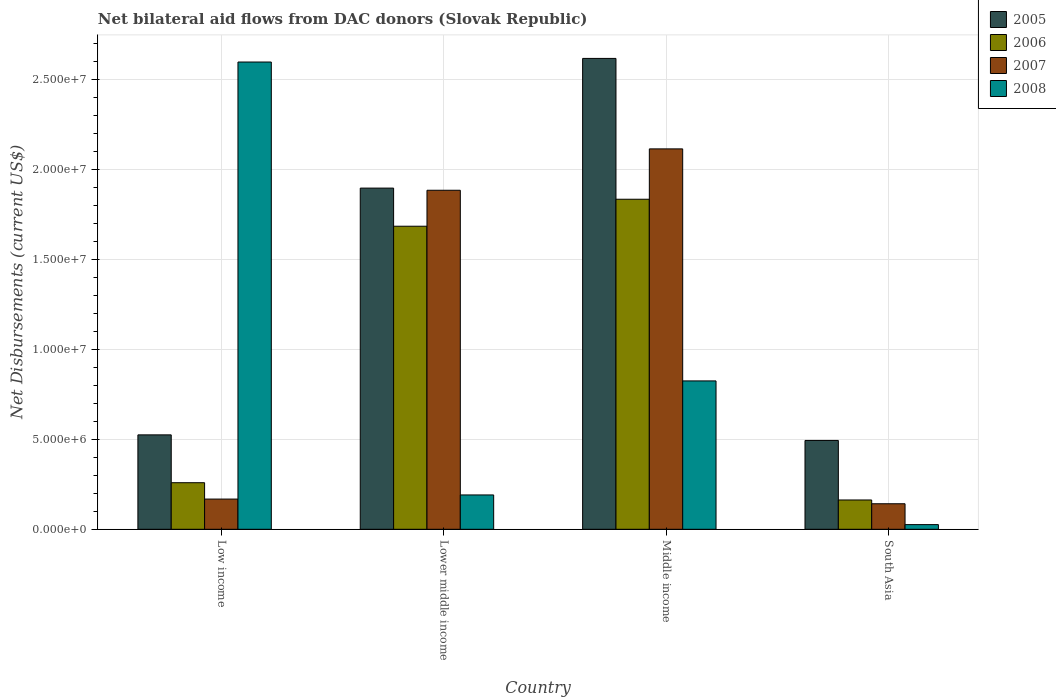Are the number of bars per tick equal to the number of legend labels?
Make the answer very short. Yes. How many bars are there on the 2nd tick from the left?
Offer a very short reply. 4. What is the label of the 1st group of bars from the left?
Offer a very short reply. Low income. In how many cases, is the number of bars for a given country not equal to the number of legend labels?
Ensure brevity in your answer.  0. What is the net bilateral aid flows in 2007 in Low income?
Give a very brief answer. 1.68e+06. Across all countries, what is the maximum net bilateral aid flows in 2008?
Make the answer very short. 2.60e+07. Across all countries, what is the minimum net bilateral aid flows in 2007?
Make the answer very short. 1.42e+06. In which country was the net bilateral aid flows in 2008 maximum?
Ensure brevity in your answer.  Low income. In which country was the net bilateral aid flows in 2005 minimum?
Ensure brevity in your answer.  South Asia. What is the total net bilateral aid flows in 2008 in the graph?
Your answer should be compact. 3.64e+07. What is the difference between the net bilateral aid flows in 2005 in Lower middle income and that in Middle income?
Offer a terse response. -7.21e+06. What is the difference between the net bilateral aid flows in 2006 in South Asia and the net bilateral aid flows in 2005 in Low income?
Offer a terse response. -3.62e+06. What is the average net bilateral aid flows in 2005 per country?
Make the answer very short. 1.38e+07. What is the difference between the net bilateral aid flows of/in 2005 and net bilateral aid flows of/in 2007 in South Asia?
Your response must be concise. 3.52e+06. What is the ratio of the net bilateral aid flows in 2007 in Low income to that in Lower middle income?
Provide a succinct answer. 0.09. What is the difference between the highest and the second highest net bilateral aid flows in 2007?
Your answer should be very brief. 1.95e+07. What is the difference between the highest and the lowest net bilateral aid flows in 2007?
Your answer should be very brief. 1.97e+07. In how many countries, is the net bilateral aid flows in 2005 greater than the average net bilateral aid flows in 2005 taken over all countries?
Offer a very short reply. 2. Is the sum of the net bilateral aid flows in 2008 in Lower middle income and Middle income greater than the maximum net bilateral aid flows in 2007 across all countries?
Make the answer very short. No. Are all the bars in the graph horizontal?
Offer a terse response. No. Does the graph contain grids?
Your answer should be compact. Yes. How are the legend labels stacked?
Your response must be concise. Vertical. What is the title of the graph?
Make the answer very short. Net bilateral aid flows from DAC donors (Slovak Republic). What is the label or title of the Y-axis?
Your response must be concise. Net Disbursements (current US$). What is the Net Disbursements (current US$) of 2005 in Low income?
Keep it short and to the point. 5.25e+06. What is the Net Disbursements (current US$) of 2006 in Low income?
Provide a succinct answer. 2.59e+06. What is the Net Disbursements (current US$) of 2007 in Low income?
Keep it short and to the point. 1.68e+06. What is the Net Disbursements (current US$) in 2008 in Low income?
Your answer should be very brief. 2.60e+07. What is the Net Disbursements (current US$) of 2005 in Lower middle income?
Your response must be concise. 1.90e+07. What is the Net Disbursements (current US$) in 2006 in Lower middle income?
Offer a very short reply. 1.68e+07. What is the Net Disbursements (current US$) in 2007 in Lower middle income?
Give a very brief answer. 1.88e+07. What is the Net Disbursements (current US$) in 2008 in Lower middle income?
Give a very brief answer. 1.91e+06. What is the Net Disbursements (current US$) of 2005 in Middle income?
Ensure brevity in your answer.  2.62e+07. What is the Net Disbursements (current US$) of 2006 in Middle income?
Offer a terse response. 1.84e+07. What is the Net Disbursements (current US$) of 2007 in Middle income?
Make the answer very short. 2.12e+07. What is the Net Disbursements (current US$) of 2008 in Middle income?
Ensure brevity in your answer.  8.25e+06. What is the Net Disbursements (current US$) of 2005 in South Asia?
Provide a succinct answer. 4.94e+06. What is the Net Disbursements (current US$) of 2006 in South Asia?
Your answer should be very brief. 1.63e+06. What is the Net Disbursements (current US$) in 2007 in South Asia?
Keep it short and to the point. 1.42e+06. What is the Net Disbursements (current US$) of 2008 in South Asia?
Ensure brevity in your answer.  2.60e+05. Across all countries, what is the maximum Net Disbursements (current US$) of 2005?
Keep it short and to the point. 2.62e+07. Across all countries, what is the maximum Net Disbursements (current US$) of 2006?
Provide a short and direct response. 1.84e+07. Across all countries, what is the maximum Net Disbursements (current US$) in 2007?
Provide a succinct answer. 2.12e+07. Across all countries, what is the maximum Net Disbursements (current US$) in 2008?
Your answer should be very brief. 2.60e+07. Across all countries, what is the minimum Net Disbursements (current US$) of 2005?
Provide a short and direct response. 4.94e+06. Across all countries, what is the minimum Net Disbursements (current US$) in 2006?
Offer a very short reply. 1.63e+06. Across all countries, what is the minimum Net Disbursements (current US$) of 2007?
Keep it short and to the point. 1.42e+06. What is the total Net Disbursements (current US$) in 2005 in the graph?
Keep it short and to the point. 5.53e+07. What is the total Net Disbursements (current US$) in 2006 in the graph?
Offer a terse response. 3.94e+07. What is the total Net Disbursements (current US$) of 2007 in the graph?
Offer a very short reply. 4.31e+07. What is the total Net Disbursements (current US$) of 2008 in the graph?
Ensure brevity in your answer.  3.64e+07. What is the difference between the Net Disbursements (current US$) in 2005 in Low income and that in Lower middle income?
Make the answer very short. -1.37e+07. What is the difference between the Net Disbursements (current US$) of 2006 in Low income and that in Lower middle income?
Provide a short and direct response. -1.43e+07. What is the difference between the Net Disbursements (current US$) of 2007 in Low income and that in Lower middle income?
Offer a terse response. -1.72e+07. What is the difference between the Net Disbursements (current US$) in 2008 in Low income and that in Lower middle income?
Keep it short and to the point. 2.41e+07. What is the difference between the Net Disbursements (current US$) of 2005 in Low income and that in Middle income?
Ensure brevity in your answer.  -2.09e+07. What is the difference between the Net Disbursements (current US$) of 2006 in Low income and that in Middle income?
Ensure brevity in your answer.  -1.58e+07. What is the difference between the Net Disbursements (current US$) of 2007 in Low income and that in Middle income?
Your answer should be compact. -1.95e+07. What is the difference between the Net Disbursements (current US$) of 2008 in Low income and that in Middle income?
Your answer should be compact. 1.77e+07. What is the difference between the Net Disbursements (current US$) in 2005 in Low income and that in South Asia?
Offer a terse response. 3.10e+05. What is the difference between the Net Disbursements (current US$) of 2006 in Low income and that in South Asia?
Give a very brief answer. 9.60e+05. What is the difference between the Net Disbursements (current US$) in 2008 in Low income and that in South Asia?
Your answer should be compact. 2.57e+07. What is the difference between the Net Disbursements (current US$) of 2005 in Lower middle income and that in Middle income?
Provide a short and direct response. -7.21e+06. What is the difference between the Net Disbursements (current US$) of 2006 in Lower middle income and that in Middle income?
Your answer should be compact. -1.50e+06. What is the difference between the Net Disbursements (current US$) of 2007 in Lower middle income and that in Middle income?
Offer a very short reply. -2.30e+06. What is the difference between the Net Disbursements (current US$) of 2008 in Lower middle income and that in Middle income?
Keep it short and to the point. -6.34e+06. What is the difference between the Net Disbursements (current US$) in 2005 in Lower middle income and that in South Asia?
Your answer should be compact. 1.40e+07. What is the difference between the Net Disbursements (current US$) of 2006 in Lower middle income and that in South Asia?
Your response must be concise. 1.52e+07. What is the difference between the Net Disbursements (current US$) of 2007 in Lower middle income and that in South Asia?
Offer a very short reply. 1.74e+07. What is the difference between the Net Disbursements (current US$) of 2008 in Lower middle income and that in South Asia?
Provide a short and direct response. 1.65e+06. What is the difference between the Net Disbursements (current US$) in 2005 in Middle income and that in South Asia?
Offer a terse response. 2.12e+07. What is the difference between the Net Disbursements (current US$) of 2006 in Middle income and that in South Asia?
Provide a succinct answer. 1.67e+07. What is the difference between the Net Disbursements (current US$) of 2007 in Middle income and that in South Asia?
Provide a succinct answer. 1.97e+07. What is the difference between the Net Disbursements (current US$) of 2008 in Middle income and that in South Asia?
Offer a terse response. 7.99e+06. What is the difference between the Net Disbursements (current US$) of 2005 in Low income and the Net Disbursements (current US$) of 2006 in Lower middle income?
Provide a short and direct response. -1.16e+07. What is the difference between the Net Disbursements (current US$) in 2005 in Low income and the Net Disbursements (current US$) in 2007 in Lower middle income?
Your answer should be compact. -1.36e+07. What is the difference between the Net Disbursements (current US$) of 2005 in Low income and the Net Disbursements (current US$) of 2008 in Lower middle income?
Keep it short and to the point. 3.34e+06. What is the difference between the Net Disbursements (current US$) of 2006 in Low income and the Net Disbursements (current US$) of 2007 in Lower middle income?
Provide a succinct answer. -1.63e+07. What is the difference between the Net Disbursements (current US$) in 2006 in Low income and the Net Disbursements (current US$) in 2008 in Lower middle income?
Your response must be concise. 6.80e+05. What is the difference between the Net Disbursements (current US$) in 2005 in Low income and the Net Disbursements (current US$) in 2006 in Middle income?
Offer a very short reply. -1.31e+07. What is the difference between the Net Disbursements (current US$) in 2005 in Low income and the Net Disbursements (current US$) in 2007 in Middle income?
Give a very brief answer. -1.59e+07. What is the difference between the Net Disbursements (current US$) in 2006 in Low income and the Net Disbursements (current US$) in 2007 in Middle income?
Offer a very short reply. -1.86e+07. What is the difference between the Net Disbursements (current US$) of 2006 in Low income and the Net Disbursements (current US$) of 2008 in Middle income?
Your answer should be very brief. -5.66e+06. What is the difference between the Net Disbursements (current US$) of 2007 in Low income and the Net Disbursements (current US$) of 2008 in Middle income?
Your answer should be compact. -6.57e+06. What is the difference between the Net Disbursements (current US$) of 2005 in Low income and the Net Disbursements (current US$) of 2006 in South Asia?
Give a very brief answer. 3.62e+06. What is the difference between the Net Disbursements (current US$) of 2005 in Low income and the Net Disbursements (current US$) of 2007 in South Asia?
Keep it short and to the point. 3.83e+06. What is the difference between the Net Disbursements (current US$) in 2005 in Low income and the Net Disbursements (current US$) in 2008 in South Asia?
Offer a terse response. 4.99e+06. What is the difference between the Net Disbursements (current US$) in 2006 in Low income and the Net Disbursements (current US$) in 2007 in South Asia?
Provide a short and direct response. 1.17e+06. What is the difference between the Net Disbursements (current US$) in 2006 in Low income and the Net Disbursements (current US$) in 2008 in South Asia?
Your response must be concise. 2.33e+06. What is the difference between the Net Disbursements (current US$) in 2007 in Low income and the Net Disbursements (current US$) in 2008 in South Asia?
Your answer should be very brief. 1.42e+06. What is the difference between the Net Disbursements (current US$) of 2005 in Lower middle income and the Net Disbursements (current US$) of 2006 in Middle income?
Your answer should be compact. 6.20e+05. What is the difference between the Net Disbursements (current US$) in 2005 in Lower middle income and the Net Disbursements (current US$) in 2007 in Middle income?
Your answer should be very brief. -2.18e+06. What is the difference between the Net Disbursements (current US$) of 2005 in Lower middle income and the Net Disbursements (current US$) of 2008 in Middle income?
Make the answer very short. 1.07e+07. What is the difference between the Net Disbursements (current US$) of 2006 in Lower middle income and the Net Disbursements (current US$) of 2007 in Middle income?
Offer a very short reply. -4.30e+06. What is the difference between the Net Disbursements (current US$) in 2006 in Lower middle income and the Net Disbursements (current US$) in 2008 in Middle income?
Provide a short and direct response. 8.60e+06. What is the difference between the Net Disbursements (current US$) of 2007 in Lower middle income and the Net Disbursements (current US$) of 2008 in Middle income?
Offer a very short reply. 1.06e+07. What is the difference between the Net Disbursements (current US$) of 2005 in Lower middle income and the Net Disbursements (current US$) of 2006 in South Asia?
Ensure brevity in your answer.  1.73e+07. What is the difference between the Net Disbursements (current US$) of 2005 in Lower middle income and the Net Disbursements (current US$) of 2007 in South Asia?
Give a very brief answer. 1.76e+07. What is the difference between the Net Disbursements (current US$) of 2005 in Lower middle income and the Net Disbursements (current US$) of 2008 in South Asia?
Offer a terse response. 1.87e+07. What is the difference between the Net Disbursements (current US$) in 2006 in Lower middle income and the Net Disbursements (current US$) in 2007 in South Asia?
Offer a terse response. 1.54e+07. What is the difference between the Net Disbursements (current US$) of 2006 in Lower middle income and the Net Disbursements (current US$) of 2008 in South Asia?
Make the answer very short. 1.66e+07. What is the difference between the Net Disbursements (current US$) of 2007 in Lower middle income and the Net Disbursements (current US$) of 2008 in South Asia?
Offer a very short reply. 1.86e+07. What is the difference between the Net Disbursements (current US$) of 2005 in Middle income and the Net Disbursements (current US$) of 2006 in South Asia?
Keep it short and to the point. 2.46e+07. What is the difference between the Net Disbursements (current US$) in 2005 in Middle income and the Net Disbursements (current US$) in 2007 in South Asia?
Offer a very short reply. 2.48e+07. What is the difference between the Net Disbursements (current US$) in 2005 in Middle income and the Net Disbursements (current US$) in 2008 in South Asia?
Provide a succinct answer. 2.59e+07. What is the difference between the Net Disbursements (current US$) in 2006 in Middle income and the Net Disbursements (current US$) in 2007 in South Asia?
Give a very brief answer. 1.69e+07. What is the difference between the Net Disbursements (current US$) in 2006 in Middle income and the Net Disbursements (current US$) in 2008 in South Asia?
Keep it short and to the point. 1.81e+07. What is the difference between the Net Disbursements (current US$) of 2007 in Middle income and the Net Disbursements (current US$) of 2008 in South Asia?
Ensure brevity in your answer.  2.09e+07. What is the average Net Disbursements (current US$) of 2005 per country?
Provide a short and direct response. 1.38e+07. What is the average Net Disbursements (current US$) of 2006 per country?
Offer a very short reply. 9.86e+06. What is the average Net Disbursements (current US$) of 2007 per country?
Your answer should be compact. 1.08e+07. What is the average Net Disbursements (current US$) in 2008 per country?
Your answer should be compact. 9.10e+06. What is the difference between the Net Disbursements (current US$) of 2005 and Net Disbursements (current US$) of 2006 in Low income?
Make the answer very short. 2.66e+06. What is the difference between the Net Disbursements (current US$) in 2005 and Net Disbursements (current US$) in 2007 in Low income?
Provide a succinct answer. 3.57e+06. What is the difference between the Net Disbursements (current US$) of 2005 and Net Disbursements (current US$) of 2008 in Low income?
Offer a terse response. -2.07e+07. What is the difference between the Net Disbursements (current US$) of 2006 and Net Disbursements (current US$) of 2007 in Low income?
Your response must be concise. 9.10e+05. What is the difference between the Net Disbursements (current US$) in 2006 and Net Disbursements (current US$) in 2008 in Low income?
Keep it short and to the point. -2.34e+07. What is the difference between the Net Disbursements (current US$) in 2007 and Net Disbursements (current US$) in 2008 in Low income?
Your response must be concise. -2.43e+07. What is the difference between the Net Disbursements (current US$) in 2005 and Net Disbursements (current US$) in 2006 in Lower middle income?
Your answer should be compact. 2.12e+06. What is the difference between the Net Disbursements (current US$) in 2005 and Net Disbursements (current US$) in 2007 in Lower middle income?
Give a very brief answer. 1.20e+05. What is the difference between the Net Disbursements (current US$) in 2005 and Net Disbursements (current US$) in 2008 in Lower middle income?
Ensure brevity in your answer.  1.71e+07. What is the difference between the Net Disbursements (current US$) in 2006 and Net Disbursements (current US$) in 2007 in Lower middle income?
Your answer should be compact. -2.00e+06. What is the difference between the Net Disbursements (current US$) of 2006 and Net Disbursements (current US$) of 2008 in Lower middle income?
Provide a succinct answer. 1.49e+07. What is the difference between the Net Disbursements (current US$) in 2007 and Net Disbursements (current US$) in 2008 in Lower middle income?
Make the answer very short. 1.69e+07. What is the difference between the Net Disbursements (current US$) in 2005 and Net Disbursements (current US$) in 2006 in Middle income?
Offer a terse response. 7.83e+06. What is the difference between the Net Disbursements (current US$) of 2005 and Net Disbursements (current US$) of 2007 in Middle income?
Keep it short and to the point. 5.03e+06. What is the difference between the Net Disbursements (current US$) of 2005 and Net Disbursements (current US$) of 2008 in Middle income?
Your answer should be compact. 1.79e+07. What is the difference between the Net Disbursements (current US$) in 2006 and Net Disbursements (current US$) in 2007 in Middle income?
Offer a terse response. -2.80e+06. What is the difference between the Net Disbursements (current US$) of 2006 and Net Disbursements (current US$) of 2008 in Middle income?
Your answer should be compact. 1.01e+07. What is the difference between the Net Disbursements (current US$) of 2007 and Net Disbursements (current US$) of 2008 in Middle income?
Ensure brevity in your answer.  1.29e+07. What is the difference between the Net Disbursements (current US$) of 2005 and Net Disbursements (current US$) of 2006 in South Asia?
Offer a very short reply. 3.31e+06. What is the difference between the Net Disbursements (current US$) of 2005 and Net Disbursements (current US$) of 2007 in South Asia?
Ensure brevity in your answer.  3.52e+06. What is the difference between the Net Disbursements (current US$) of 2005 and Net Disbursements (current US$) of 2008 in South Asia?
Offer a terse response. 4.68e+06. What is the difference between the Net Disbursements (current US$) in 2006 and Net Disbursements (current US$) in 2008 in South Asia?
Make the answer very short. 1.37e+06. What is the difference between the Net Disbursements (current US$) of 2007 and Net Disbursements (current US$) of 2008 in South Asia?
Ensure brevity in your answer.  1.16e+06. What is the ratio of the Net Disbursements (current US$) in 2005 in Low income to that in Lower middle income?
Provide a succinct answer. 0.28. What is the ratio of the Net Disbursements (current US$) of 2006 in Low income to that in Lower middle income?
Make the answer very short. 0.15. What is the ratio of the Net Disbursements (current US$) of 2007 in Low income to that in Lower middle income?
Offer a terse response. 0.09. What is the ratio of the Net Disbursements (current US$) in 2008 in Low income to that in Lower middle income?
Provide a succinct answer. 13.6. What is the ratio of the Net Disbursements (current US$) in 2005 in Low income to that in Middle income?
Provide a short and direct response. 0.2. What is the ratio of the Net Disbursements (current US$) in 2006 in Low income to that in Middle income?
Your answer should be compact. 0.14. What is the ratio of the Net Disbursements (current US$) of 2007 in Low income to that in Middle income?
Make the answer very short. 0.08. What is the ratio of the Net Disbursements (current US$) in 2008 in Low income to that in Middle income?
Your answer should be compact. 3.15. What is the ratio of the Net Disbursements (current US$) of 2005 in Low income to that in South Asia?
Keep it short and to the point. 1.06. What is the ratio of the Net Disbursements (current US$) in 2006 in Low income to that in South Asia?
Keep it short and to the point. 1.59. What is the ratio of the Net Disbursements (current US$) in 2007 in Low income to that in South Asia?
Provide a short and direct response. 1.18. What is the ratio of the Net Disbursements (current US$) in 2008 in Low income to that in South Asia?
Your answer should be compact. 99.92. What is the ratio of the Net Disbursements (current US$) of 2005 in Lower middle income to that in Middle income?
Provide a succinct answer. 0.72. What is the ratio of the Net Disbursements (current US$) of 2006 in Lower middle income to that in Middle income?
Provide a succinct answer. 0.92. What is the ratio of the Net Disbursements (current US$) in 2007 in Lower middle income to that in Middle income?
Make the answer very short. 0.89. What is the ratio of the Net Disbursements (current US$) in 2008 in Lower middle income to that in Middle income?
Offer a very short reply. 0.23. What is the ratio of the Net Disbursements (current US$) of 2005 in Lower middle income to that in South Asia?
Offer a terse response. 3.84. What is the ratio of the Net Disbursements (current US$) in 2006 in Lower middle income to that in South Asia?
Offer a terse response. 10.34. What is the ratio of the Net Disbursements (current US$) in 2007 in Lower middle income to that in South Asia?
Give a very brief answer. 13.27. What is the ratio of the Net Disbursements (current US$) in 2008 in Lower middle income to that in South Asia?
Keep it short and to the point. 7.35. What is the ratio of the Net Disbursements (current US$) in 2005 in Middle income to that in South Asia?
Your answer should be compact. 5.3. What is the ratio of the Net Disbursements (current US$) of 2006 in Middle income to that in South Asia?
Your answer should be very brief. 11.26. What is the ratio of the Net Disbursements (current US$) of 2007 in Middle income to that in South Asia?
Offer a very short reply. 14.89. What is the ratio of the Net Disbursements (current US$) of 2008 in Middle income to that in South Asia?
Make the answer very short. 31.73. What is the difference between the highest and the second highest Net Disbursements (current US$) in 2005?
Provide a succinct answer. 7.21e+06. What is the difference between the highest and the second highest Net Disbursements (current US$) in 2006?
Your answer should be very brief. 1.50e+06. What is the difference between the highest and the second highest Net Disbursements (current US$) of 2007?
Offer a very short reply. 2.30e+06. What is the difference between the highest and the second highest Net Disbursements (current US$) of 2008?
Make the answer very short. 1.77e+07. What is the difference between the highest and the lowest Net Disbursements (current US$) in 2005?
Give a very brief answer. 2.12e+07. What is the difference between the highest and the lowest Net Disbursements (current US$) in 2006?
Offer a terse response. 1.67e+07. What is the difference between the highest and the lowest Net Disbursements (current US$) in 2007?
Make the answer very short. 1.97e+07. What is the difference between the highest and the lowest Net Disbursements (current US$) of 2008?
Your answer should be very brief. 2.57e+07. 